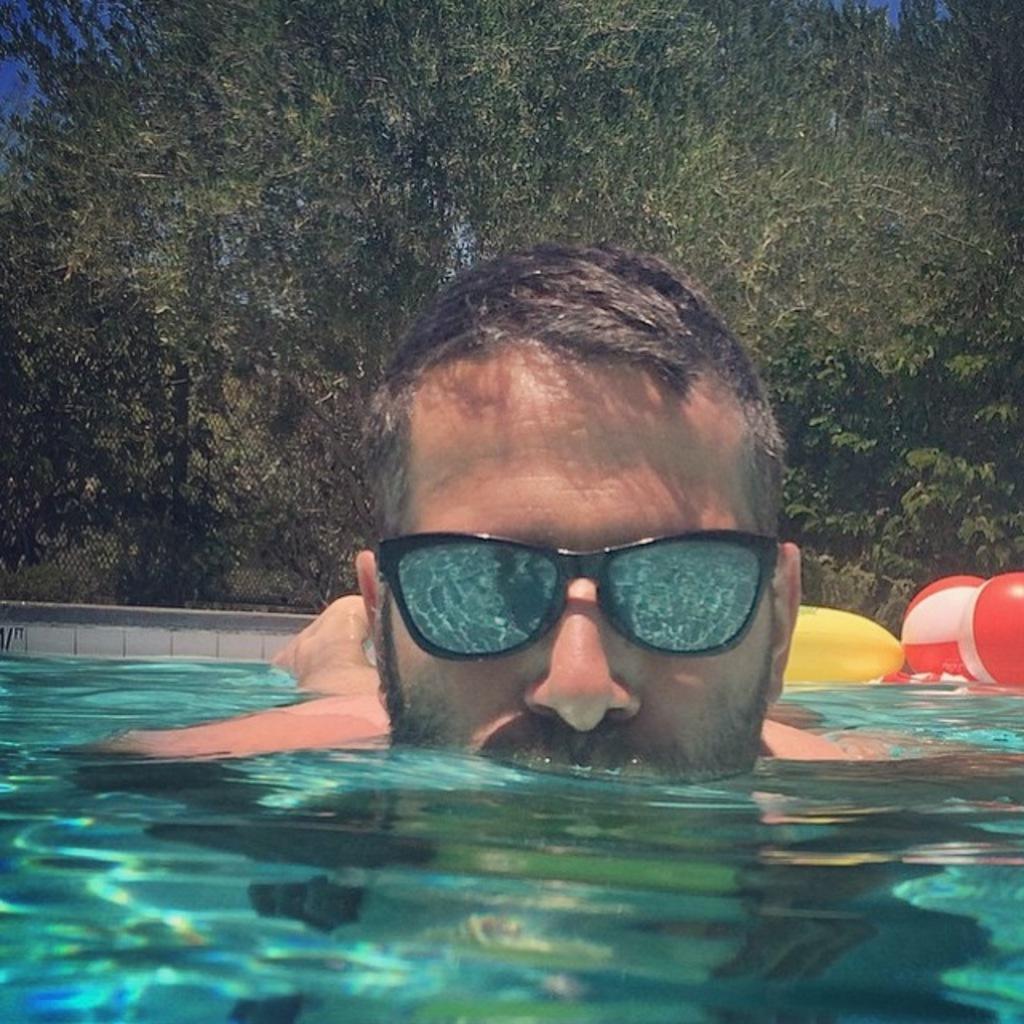Describe this image in one or two sentences. In this picture we can see water, balls, yellow object, wall and a man wore goggles and in the background we can see trees. 